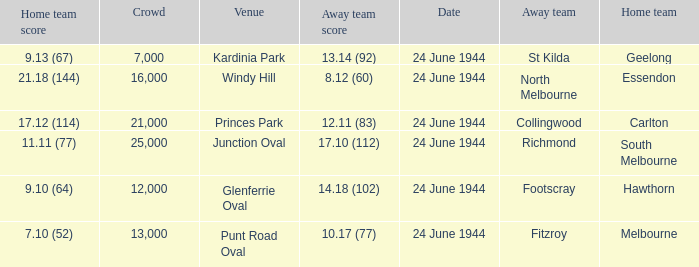When the Crowd was larger than 25,000. what was the Home Team score? None. Can you parse all the data within this table? {'header': ['Home team score', 'Crowd', 'Venue', 'Away team score', 'Date', 'Away team', 'Home team'], 'rows': [['9.13 (67)', '7,000', 'Kardinia Park', '13.14 (92)', '24 June 1944', 'St Kilda', 'Geelong'], ['21.18 (144)', '16,000', 'Windy Hill', '8.12 (60)', '24 June 1944', 'North Melbourne', 'Essendon'], ['17.12 (114)', '21,000', 'Princes Park', '12.11 (83)', '24 June 1944', 'Collingwood', 'Carlton'], ['11.11 (77)', '25,000', 'Junction Oval', '17.10 (112)', '24 June 1944', 'Richmond', 'South Melbourne'], ['9.10 (64)', '12,000', 'Glenferrie Oval', '14.18 (102)', '24 June 1944', 'Footscray', 'Hawthorn'], ['7.10 (52)', '13,000', 'Punt Road Oval', '10.17 (77)', '24 June 1944', 'Fitzroy', 'Melbourne']]} 